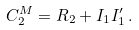Convert formula to latex. <formula><loc_0><loc_0><loc_500><loc_500>C ^ { M } _ { 2 } = R _ { 2 } + I _ { 1 } I ^ { \prime } _ { 1 } \, .</formula> 